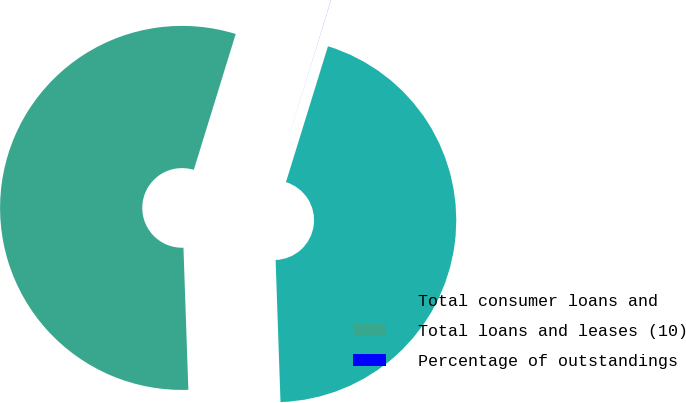Convert chart to OTSL. <chart><loc_0><loc_0><loc_500><loc_500><pie_chart><fcel>Total consumer loans and<fcel>Total loans and leases (10)<fcel>Percentage of outstandings<nl><fcel>44.68%<fcel>55.31%<fcel>0.01%<nl></chart> 